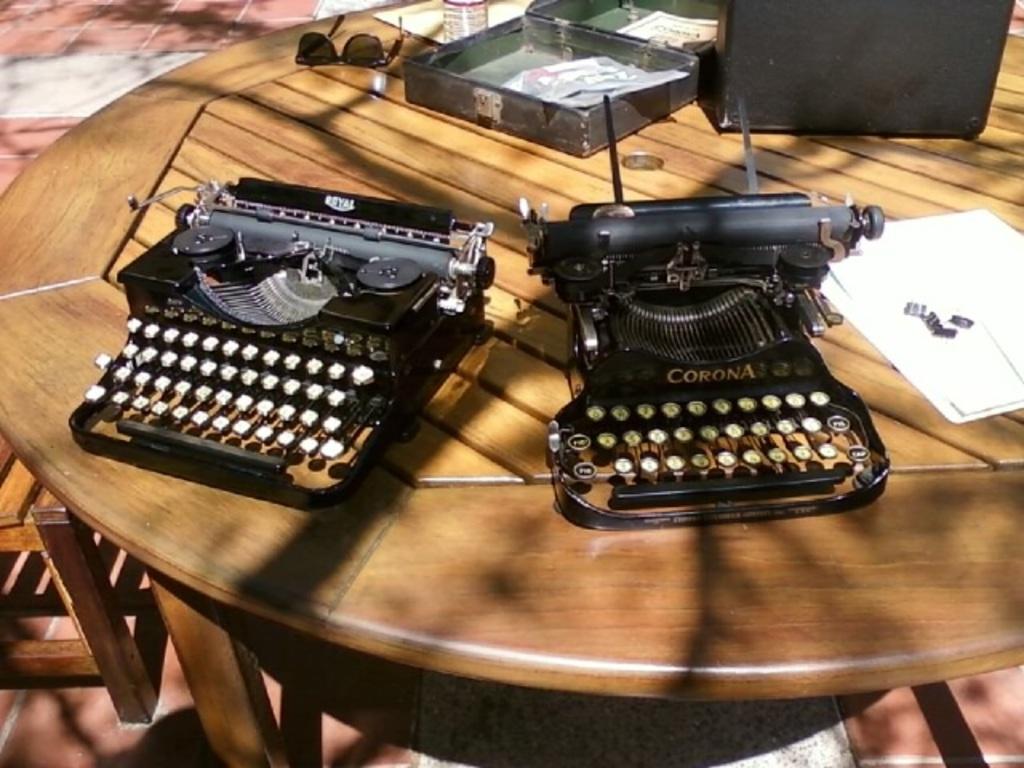What brand of typewriter is on the right?
Provide a short and direct response. Corona. 